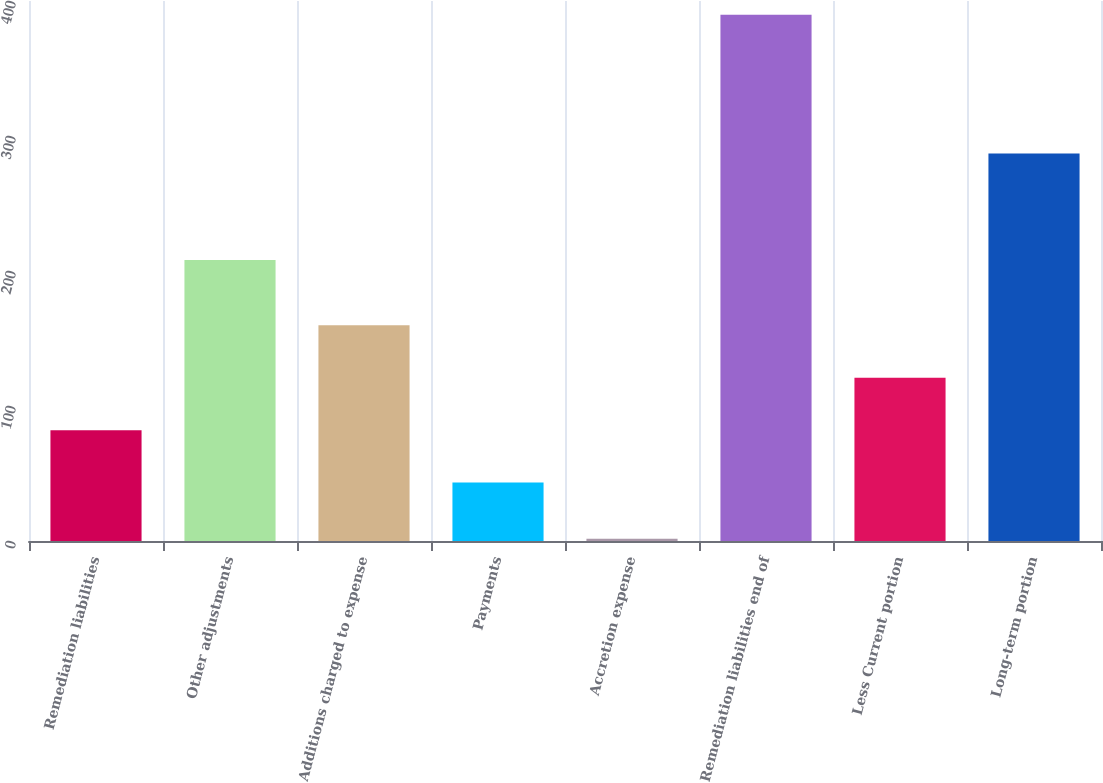Convert chart to OTSL. <chart><loc_0><loc_0><loc_500><loc_500><bar_chart><fcel>Remediation liabilities<fcel>Other adjustments<fcel>Additions charged to expense<fcel>Payments<fcel>Accretion expense<fcel>Remediation liabilities end of<fcel>Less Current portion<fcel>Long-term portion<nl><fcel>82.12<fcel>208.1<fcel>159.76<fcel>43.3<fcel>1.7<fcel>389.9<fcel>120.94<fcel>287.1<nl></chart> 